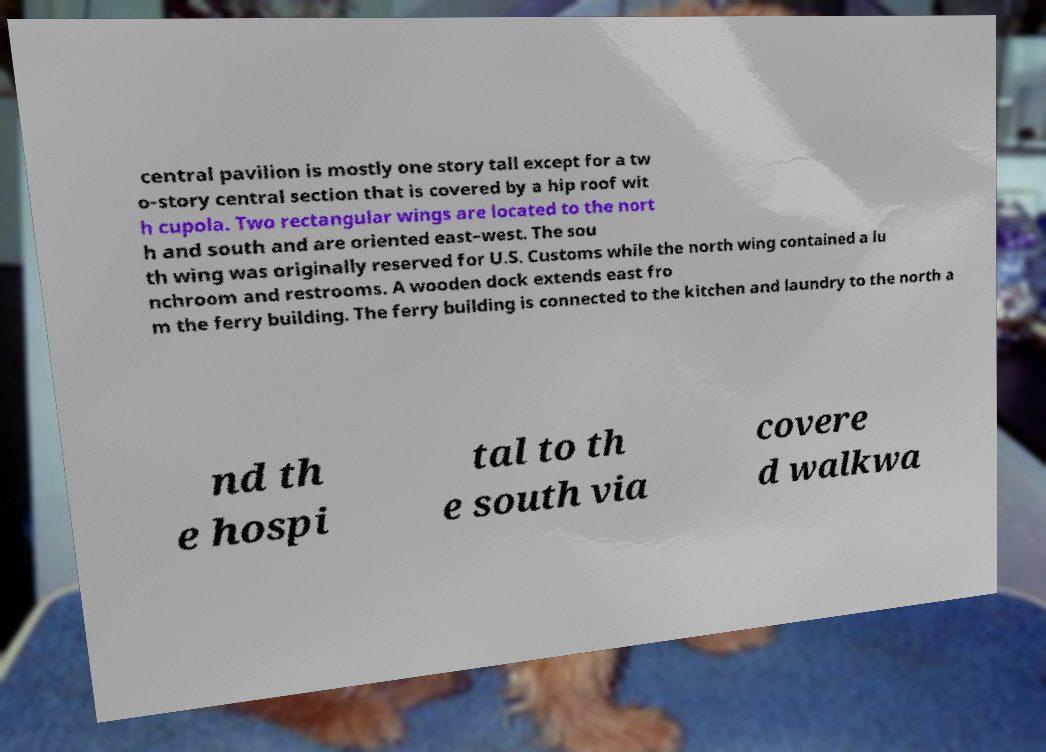I need the written content from this picture converted into text. Can you do that? central pavilion is mostly one story tall except for a tw o-story central section that is covered by a hip roof wit h cupola. Two rectangular wings are located to the nort h and south and are oriented east–west. The sou th wing was originally reserved for U.S. Customs while the north wing contained a lu nchroom and restrooms. A wooden dock extends east fro m the ferry building. The ferry building is connected to the kitchen and laundry to the north a nd th e hospi tal to th e south via covere d walkwa 